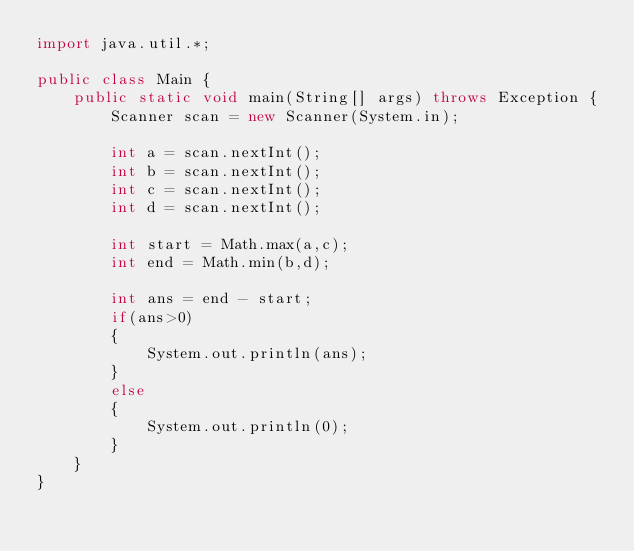Convert code to text. <code><loc_0><loc_0><loc_500><loc_500><_Java_>import java.util.*;

public class Main {
    public static void main(String[] args) throws Exception {
        Scanner scan = new Scanner(System.in);
        
        int a = scan.nextInt();
        int b = scan.nextInt();
        int c = scan.nextInt();
        int d = scan.nextInt();
        
        int start = Math.max(a,c);
        int end = Math.min(b,d);
        
        int ans = end - start;
        if(ans>0)
        {
            System.out.println(ans);
        }
        else
        {
            System.out.println(0);
        }
    }
}</code> 